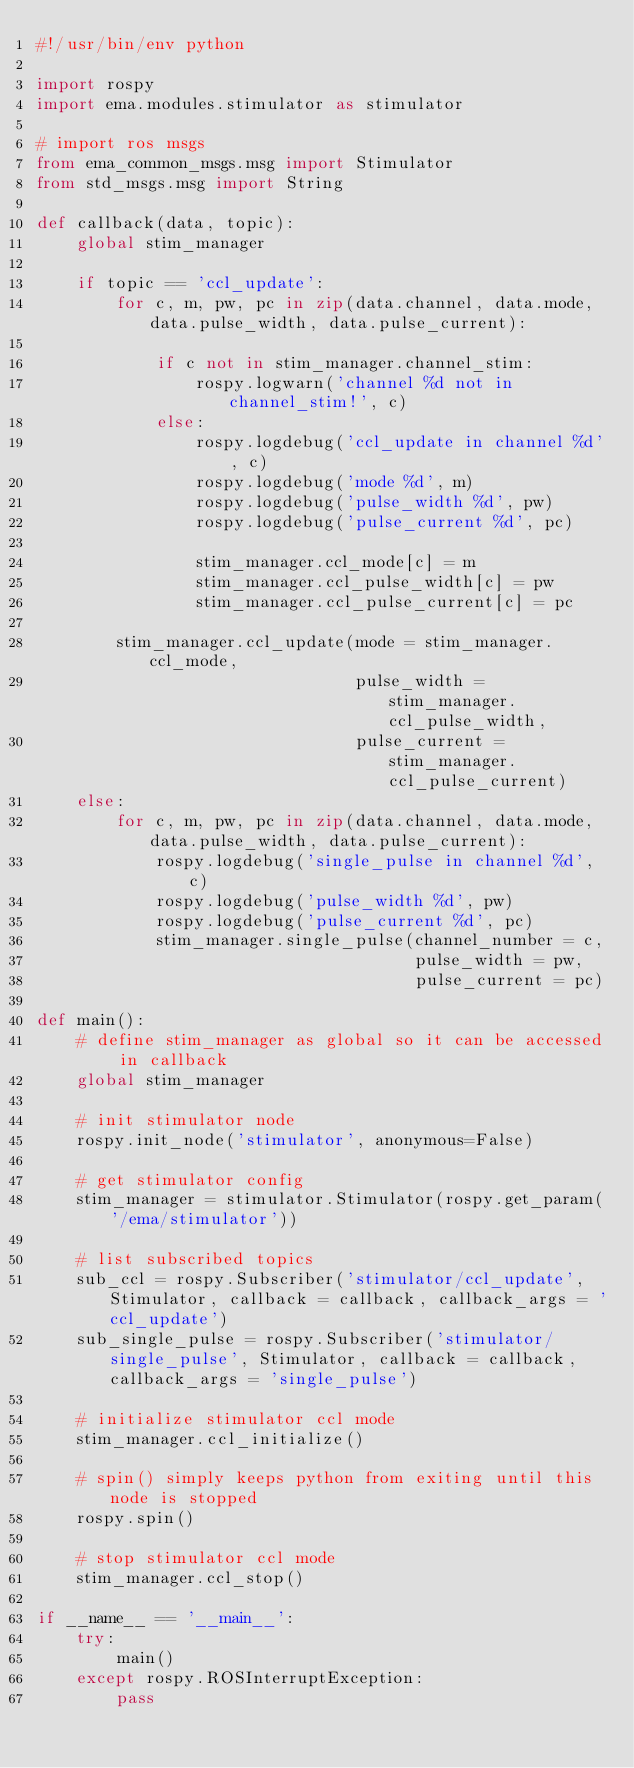Convert code to text. <code><loc_0><loc_0><loc_500><loc_500><_Python_>#!/usr/bin/env python

import rospy
import ema.modules.stimulator as stimulator

# import ros msgs
from ema_common_msgs.msg import Stimulator
from std_msgs.msg import String

def callback(data, topic):
    global stim_manager

    if topic == 'ccl_update':
        for c, m, pw, pc in zip(data.channel, data.mode, data.pulse_width, data.pulse_current):

            if c not in stim_manager.channel_stim:
                rospy.logwarn('channel %d not in channel_stim!', c)
            else:
                rospy.logdebug('ccl_update in channel %d', c)
                rospy.logdebug('mode %d', m)
                rospy.logdebug('pulse_width %d', pw)
                rospy.logdebug('pulse_current %d', pc)

                stim_manager.ccl_mode[c] = m
                stim_manager.ccl_pulse_width[c] = pw
                stim_manager.ccl_pulse_current[c] = pc

        stim_manager.ccl_update(mode = stim_manager.ccl_mode,
                                pulse_width = stim_manager.ccl_pulse_width,
                                pulse_current = stim_manager.ccl_pulse_current)
    else:
        for c, m, pw, pc in zip(data.channel, data.mode, data.pulse_width, data.pulse_current):
            rospy.logdebug('single_pulse in channel %d', c)
            rospy.logdebug('pulse_width %d', pw)
            rospy.logdebug('pulse_current %d', pc)
            stim_manager.single_pulse(channel_number = c,
                                      pulse_width = pw,
                                      pulse_current = pc)

def main():
    # define stim_manager as global so it can be accessed in callback
    global stim_manager

    # init stimulator node
    rospy.init_node('stimulator', anonymous=False)

    # get stimulator config
    stim_manager = stimulator.Stimulator(rospy.get_param('/ema/stimulator'))

    # list subscribed topics
    sub_ccl = rospy.Subscriber('stimulator/ccl_update', Stimulator, callback = callback, callback_args = 'ccl_update')
    sub_single_pulse = rospy.Subscriber('stimulator/single_pulse', Stimulator, callback = callback, callback_args = 'single_pulse')

    # initialize stimulator ccl mode
    stim_manager.ccl_initialize()

    # spin() simply keeps python from exiting until this node is stopped
    rospy.spin()

    # stop stimulator ccl mode
    stim_manager.ccl_stop()

if __name__ == '__main__':
    try:
        main()
    except rospy.ROSInterruptException:
        pass
</code> 